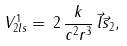Convert formula to latex. <formula><loc_0><loc_0><loc_500><loc_500>V ^ { 1 } _ { 2 l s } = \, 2 \, \frac { k } { c ^ { 2 } r ^ { 3 } } \, \vec { l } \vec { s } _ { 2 } ,</formula> 